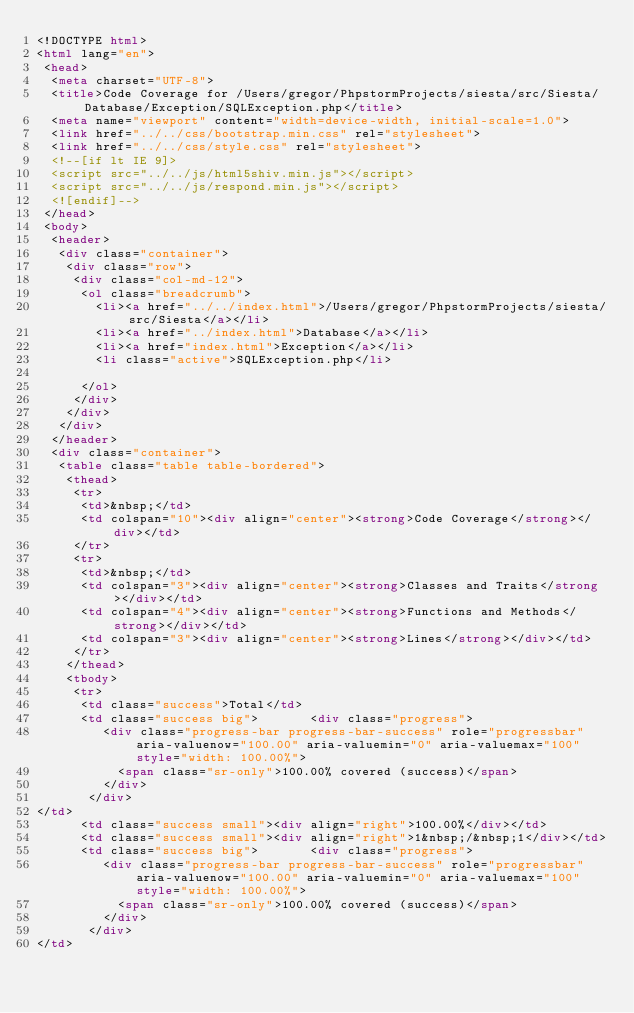<code> <loc_0><loc_0><loc_500><loc_500><_HTML_><!DOCTYPE html>
<html lang="en">
 <head>
  <meta charset="UTF-8">
  <title>Code Coverage for /Users/gregor/PhpstormProjects/siesta/src/Siesta/Database/Exception/SQLException.php</title>
  <meta name="viewport" content="width=device-width, initial-scale=1.0">
  <link href="../../css/bootstrap.min.css" rel="stylesheet">
  <link href="../../css/style.css" rel="stylesheet">
  <!--[if lt IE 9]>
  <script src="../../js/html5shiv.min.js"></script>
  <script src="../../js/respond.min.js"></script>
  <![endif]-->
 </head>
 <body>
  <header>
   <div class="container">
    <div class="row">
     <div class="col-md-12">
      <ol class="breadcrumb">
        <li><a href="../../index.html">/Users/gregor/PhpstormProjects/siesta/src/Siesta</a></li>
        <li><a href="../index.html">Database</a></li>
        <li><a href="index.html">Exception</a></li>
        <li class="active">SQLException.php</li>

      </ol>
     </div>
    </div>
   </div>
  </header>
  <div class="container">
   <table class="table table-bordered">
    <thead>
     <tr>
      <td>&nbsp;</td>
      <td colspan="10"><div align="center"><strong>Code Coverage</strong></div></td>
     </tr>
     <tr>
      <td>&nbsp;</td>
      <td colspan="3"><div align="center"><strong>Classes and Traits</strong></div></td>
      <td colspan="4"><div align="center"><strong>Functions and Methods</strong></div></td>
      <td colspan="3"><div align="center"><strong>Lines</strong></div></td>
     </tr>
    </thead>
    <tbody>
     <tr>
      <td class="success">Total</td>
      <td class="success big">       <div class="progress">
         <div class="progress-bar progress-bar-success" role="progressbar" aria-valuenow="100.00" aria-valuemin="0" aria-valuemax="100" style="width: 100.00%">
           <span class="sr-only">100.00% covered (success)</span>
         </div>
       </div>
</td>
      <td class="success small"><div align="right">100.00%</div></td>
      <td class="success small"><div align="right">1&nbsp;/&nbsp;1</div></td>
      <td class="success big">       <div class="progress">
         <div class="progress-bar progress-bar-success" role="progressbar" aria-valuenow="100.00" aria-valuemin="0" aria-valuemax="100" style="width: 100.00%">
           <span class="sr-only">100.00% covered (success)</span>
         </div>
       </div>
</td></code> 